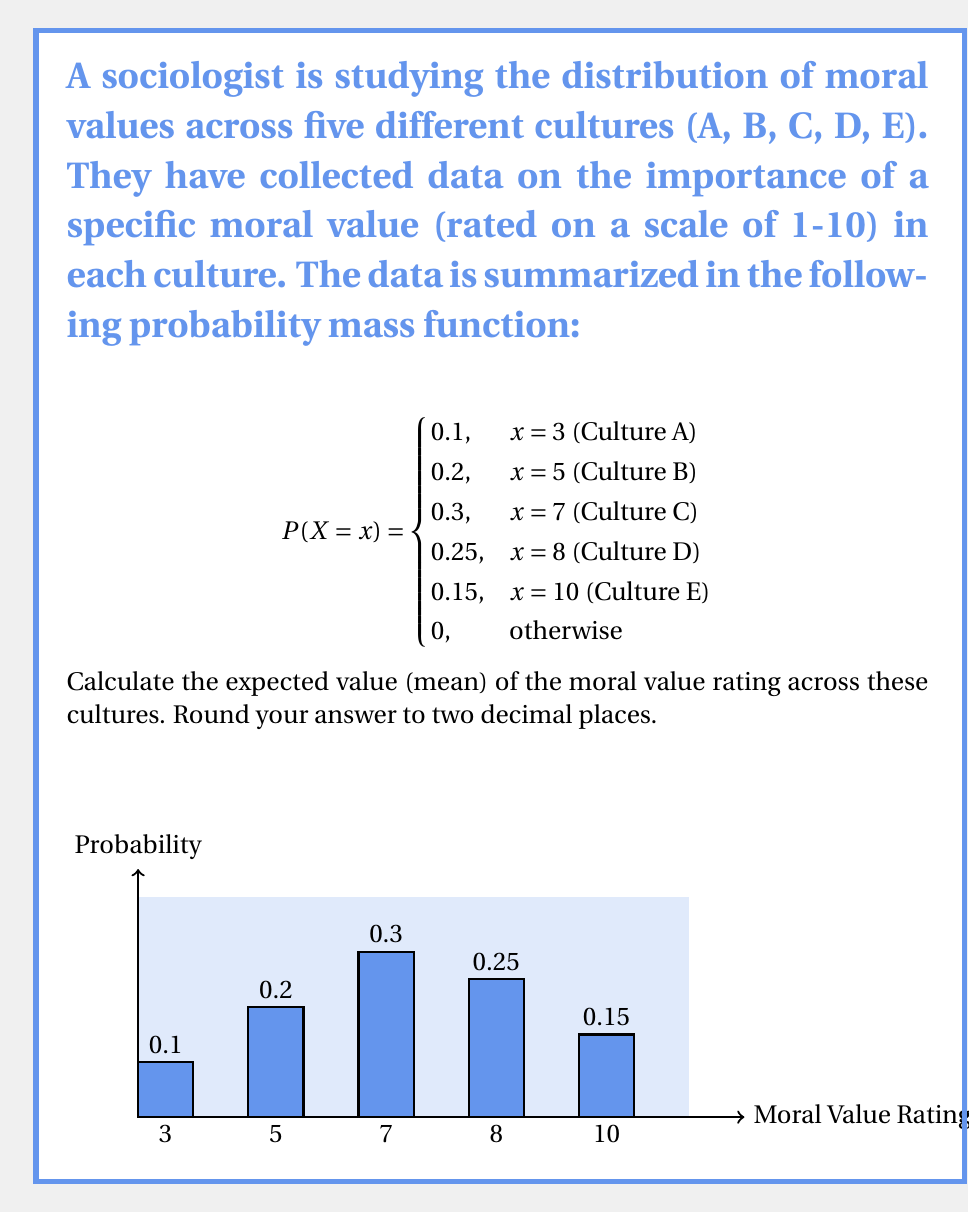Can you answer this question? To calculate the expected value (mean) of the moral value rating, we need to use the formula for the expected value of a discrete random variable:

$$E(X) = \sum_{x} x \cdot P(X = x)$$

Let's break it down step-by-step:

1) First, we multiply each possible value of X by its probability:

   For Culture A: $3 \cdot 0.1 = 0.3$
   For Culture B: $5 \cdot 0.2 = 1.0$
   For Culture C: $7 \cdot 0.3 = 2.1$
   For Culture D: $8 \cdot 0.25 = 2.0$
   For Culture E: $10 \cdot 0.15 = 1.5$

2) Now, we sum all these products:

   $$E(X) = 0.3 + 1.0 + 2.1 + 2.0 + 1.5$$

3) Calculating the sum:

   $$E(X) = 6.9$$

4) Rounding to two decimal places:

   $$E(X) \approx 6.90$$

Therefore, the expected value (mean) of the moral value rating across these cultures is 6.90.
Answer: 6.90 